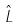Convert formula to latex. <formula><loc_0><loc_0><loc_500><loc_500>\hat { L }</formula> 